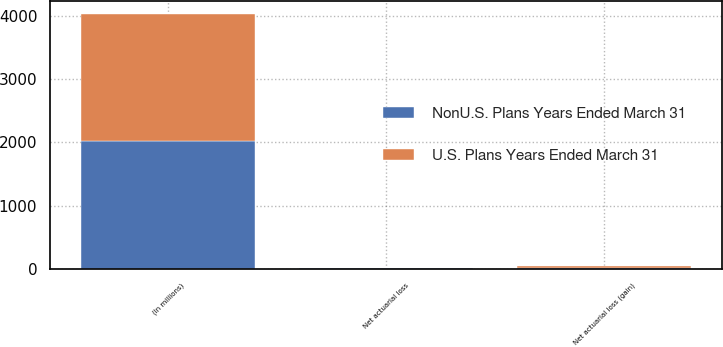<chart> <loc_0><loc_0><loc_500><loc_500><stacked_bar_chart><ecel><fcel>(In millions)<fcel>Net actuarial loss (gain)<fcel>Net actuarial loss<nl><fcel>NonU.S. Plans Years Ended March 31<fcel>2019<fcel>8<fcel>9<nl><fcel>U.S. Plans Years Ended March 31<fcel>2019<fcel>42<fcel>5<nl></chart> 